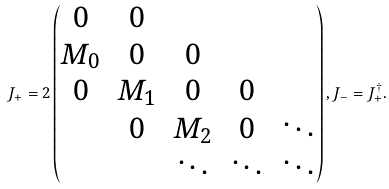<formula> <loc_0><loc_0><loc_500><loc_500>J _ { + } = 2 \left ( \begin{matrix} 0 & 0 & & & \\ M _ { 0 } & 0 & 0 & & \\ 0 & M _ { 1 } & 0 & 0 & \\ & 0 & M _ { 2 } & 0 & \ddots \\ & & \ddots & \ddots & \ddots \end{matrix} \right ) , J _ { - } = J _ { + } ^ { \dagger } .</formula> 